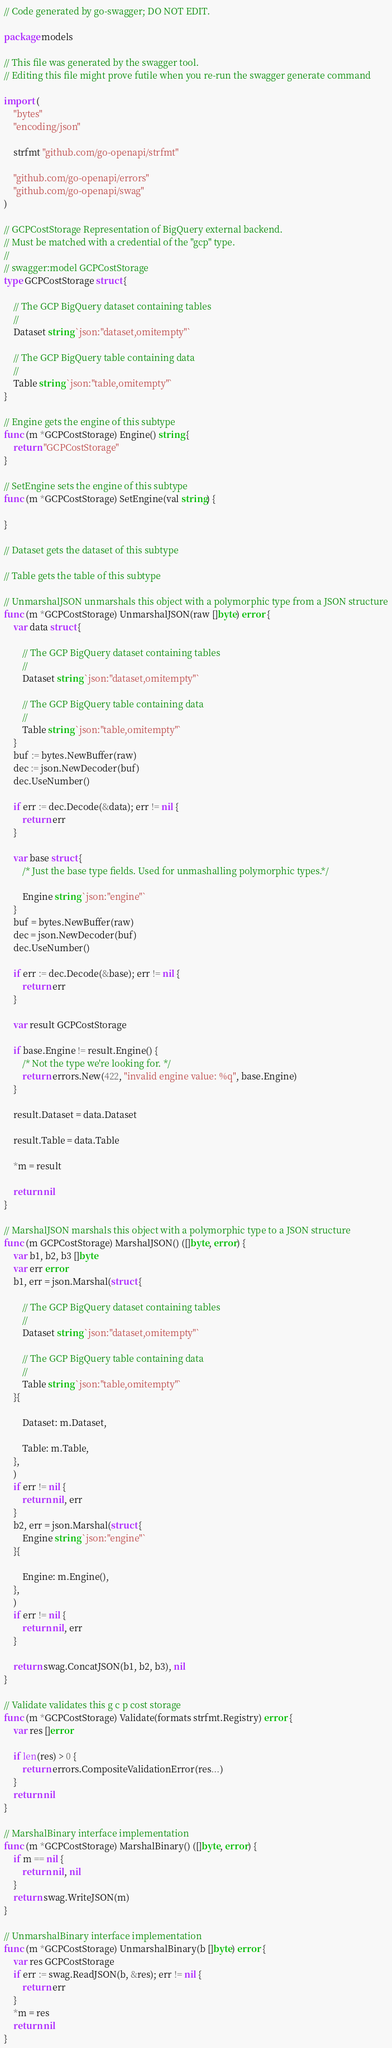<code> <loc_0><loc_0><loc_500><loc_500><_Go_>// Code generated by go-swagger; DO NOT EDIT.

package models

// This file was generated by the swagger tool.
// Editing this file might prove futile when you re-run the swagger generate command

import (
	"bytes"
	"encoding/json"

	strfmt "github.com/go-openapi/strfmt"

	"github.com/go-openapi/errors"
	"github.com/go-openapi/swag"
)

// GCPCostStorage Representation of BigQuery external backend.
// Must be matched with a credential of the "gcp" type.
//
// swagger:model GCPCostStorage
type GCPCostStorage struct {

	// The GCP BigQuery dataset containing tables
	//
	Dataset string `json:"dataset,omitempty"`

	// The GCP BigQuery table containing data
	//
	Table string `json:"table,omitempty"`
}

// Engine gets the engine of this subtype
func (m *GCPCostStorage) Engine() string {
	return "GCPCostStorage"
}

// SetEngine sets the engine of this subtype
func (m *GCPCostStorage) SetEngine(val string) {

}

// Dataset gets the dataset of this subtype

// Table gets the table of this subtype

// UnmarshalJSON unmarshals this object with a polymorphic type from a JSON structure
func (m *GCPCostStorage) UnmarshalJSON(raw []byte) error {
	var data struct {

		// The GCP BigQuery dataset containing tables
		//
		Dataset string `json:"dataset,omitempty"`

		// The GCP BigQuery table containing data
		//
		Table string `json:"table,omitempty"`
	}
	buf := bytes.NewBuffer(raw)
	dec := json.NewDecoder(buf)
	dec.UseNumber()

	if err := dec.Decode(&data); err != nil {
		return err
	}

	var base struct {
		/* Just the base type fields. Used for unmashalling polymorphic types.*/

		Engine string `json:"engine"`
	}
	buf = bytes.NewBuffer(raw)
	dec = json.NewDecoder(buf)
	dec.UseNumber()

	if err := dec.Decode(&base); err != nil {
		return err
	}

	var result GCPCostStorage

	if base.Engine != result.Engine() {
		/* Not the type we're looking for. */
		return errors.New(422, "invalid engine value: %q", base.Engine)
	}

	result.Dataset = data.Dataset

	result.Table = data.Table

	*m = result

	return nil
}

// MarshalJSON marshals this object with a polymorphic type to a JSON structure
func (m GCPCostStorage) MarshalJSON() ([]byte, error) {
	var b1, b2, b3 []byte
	var err error
	b1, err = json.Marshal(struct {

		// The GCP BigQuery dataset containing tables
		//
		Dataset string `json:"dataset,omitempty"`

		// The GCP BigQuery table containing data
		//
		Table string `json:"table,omitempty"`
	}{

		Dataset: m.Dataset,

		Table: m.Table,
	},
	)
	if err != nil {
		return nil, err
	}
	b2, err = json.Marshal(struct {
		Engine string `json:"engine"`
	}{

		Engine: m.Engine(),
	},
	)
	if err != nil {
		return nil, err
	}

	return swag.ConcatJSON(b1, b2, b3), nil
}

// Validate validates this g c p cost storage
func (m *GCPCostStorage) Validate(formats strfmt.Registry) error {
	var res []error

	if len(res) > 0 {
		return errors.CompositeValidationError(res...)
	}
	return nil
}

// MarshalBinary interface implementation
func (m *GCPCostStorage) MarshalBinary() ([]byte, error) {
	if m == nil {
		return nil, nil
	}
	return swag.WriteJSON(m)
}

// UnmarshalBinary interface implementation
func (m *GCPCostStorage) UnmarshalBinary(b []byte) error {
	var res GCPCostStorage
	if err := swag.ReadJSON(b, &res); err != nil {
		return err
	}
	*m = res
	return nil
}
</code> 